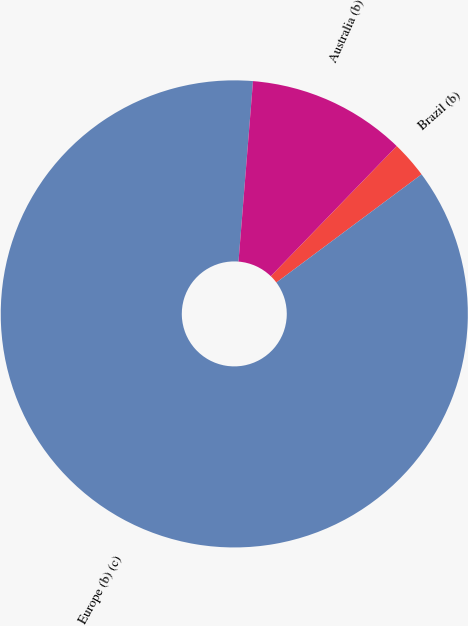<chart> <loc_0><loc_0><loc_500><loc_500><pie_chart><fcel>Brazil (b)<fcel>Europe (b) (c)<fcel>Australia (b)<nl><fcel>2.57%<fcel>86.46%<fcel>10.96%<nl></chart> 